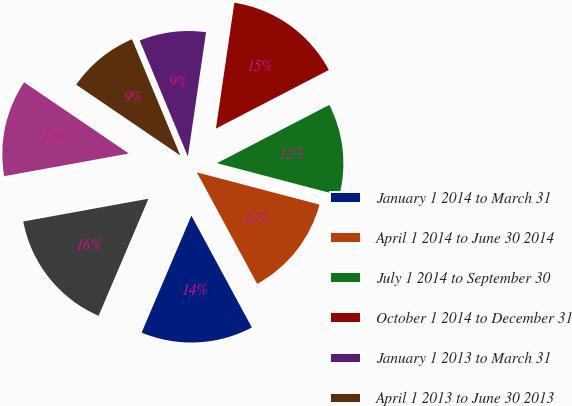Convert chart. <chart><loc_0><loc_0><loc_500><loc_500><pie_chart><fcel>January 1 2014 to March 31<fcel>April 1 2014 to June 30 2014<fcel>July 1 2014 to September 30<fcel>October 1 2014 to December 31<fcel>January 1 2013 to March 31<fcel>April 1 2013 to June 30 2013<fcel>July 1 2013 to September 30<fcel>October 1 2013 to December 31<nl><fcel>14.3%<fcel>13.02%<fcel>11.71%<fcel>15.07%<fcel>8.58%<fcel>9.23%<fcel>12.37%<fcel>15.73%<nl></chart> 